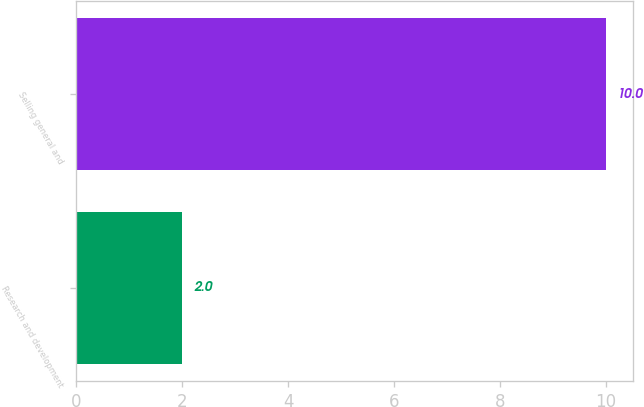Convert chart to OTSL. <chart><loc_0><loc_0><loc_500><loc_500><bar_chart><fcel>Research and development<fcel>Selling general and<nl><fcel>2<fcel>10<nl></chart> 